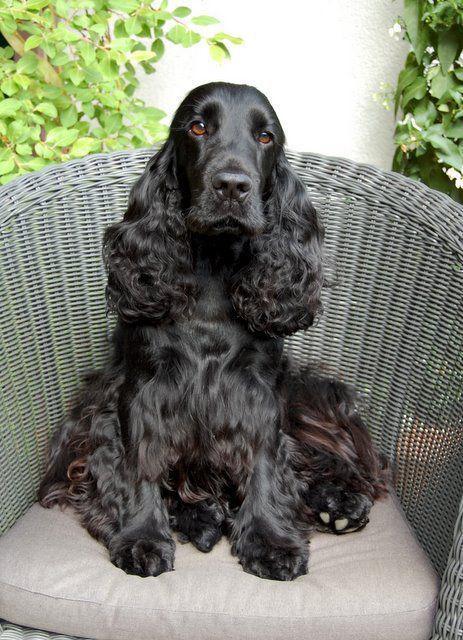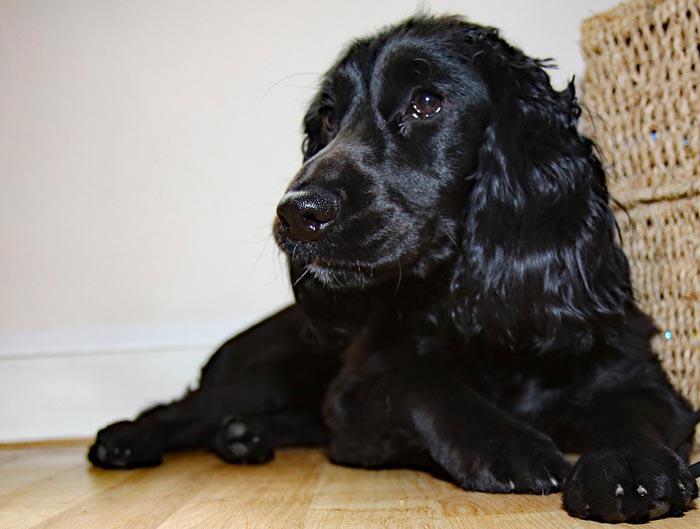The first image is the image on the left, the second image is the image on the right. Assess this claim about the two images: "At least one dog is being held in someone's hands.". Correct or not? Answer yes or no. No. The first image is the image on the left, the second image is the image on the right. For the images shown, is this caption "the right pic has human shoes in it" true? Answer yes or no. No. 